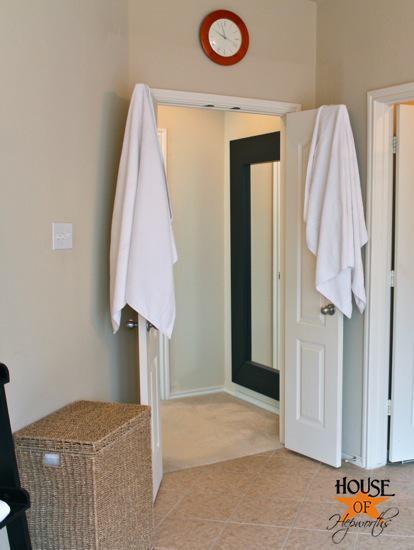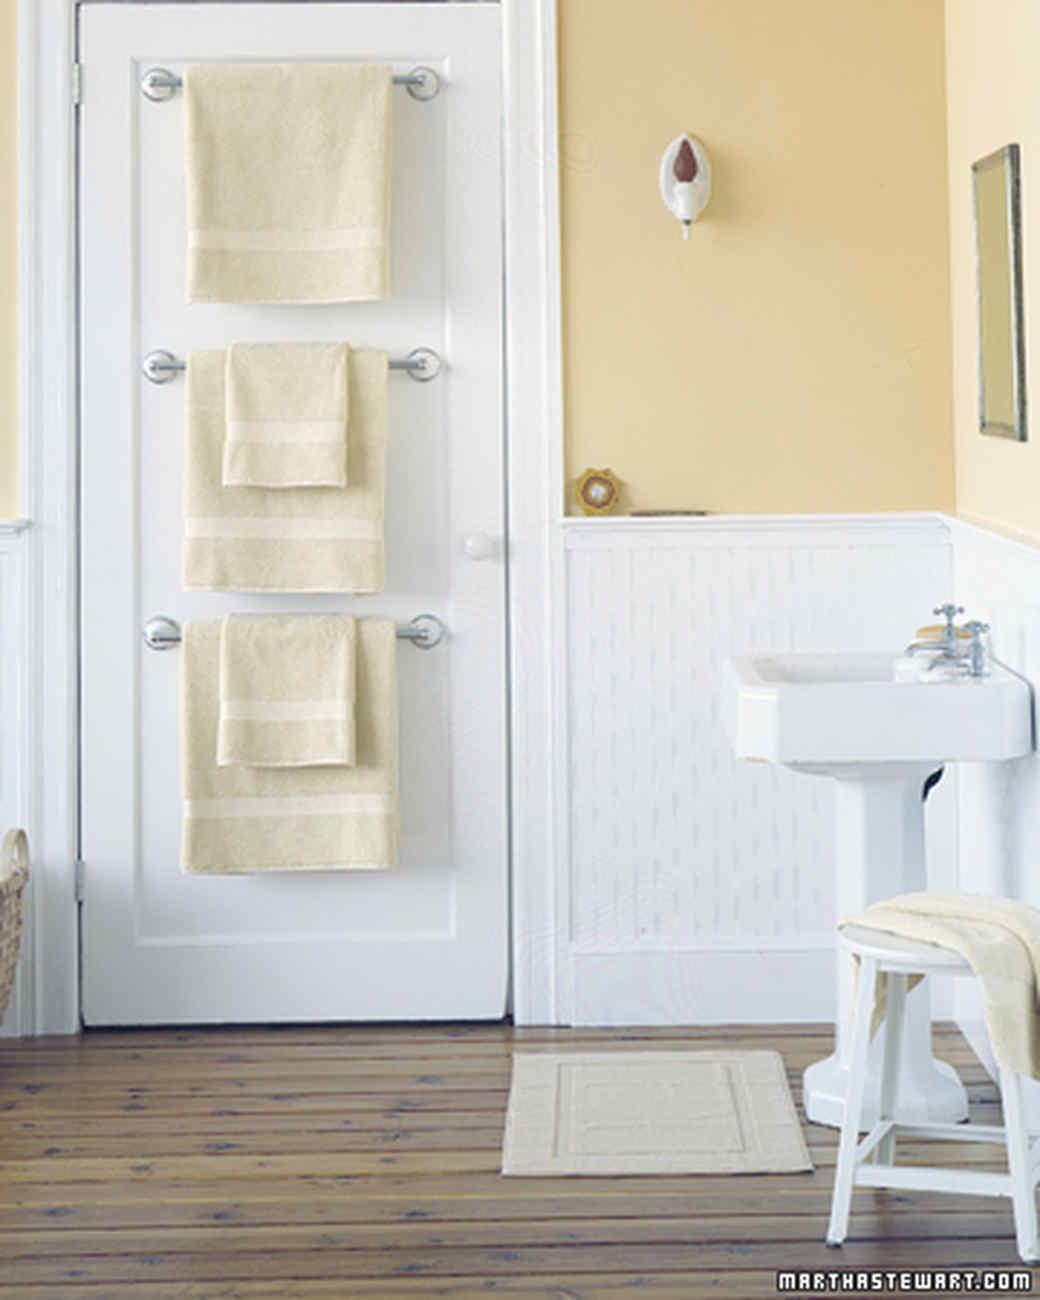The first image is the image on the left, the second image is the image on the right. Considering the images on both sides, is "Exactly two towels hang from hooks in one image." valid? Answer yes or no. No. 